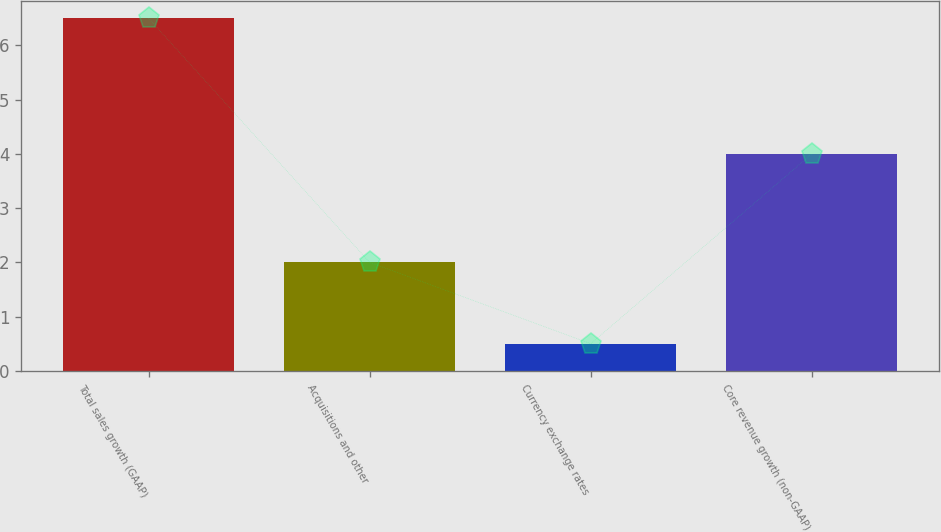Convert chart. <chart><loc_0><loc_0><loc_500><loc_500><bar_chart><fcel>Total sales growth (GAAP)<fcel>Acquisitions and other<fcel>Currency exchange rates<fcel>Core revenue growth (non-GAAP)<nl><fcel>6.5<fcel>2<fcel>0.5<fcel>4<nl></chart> 